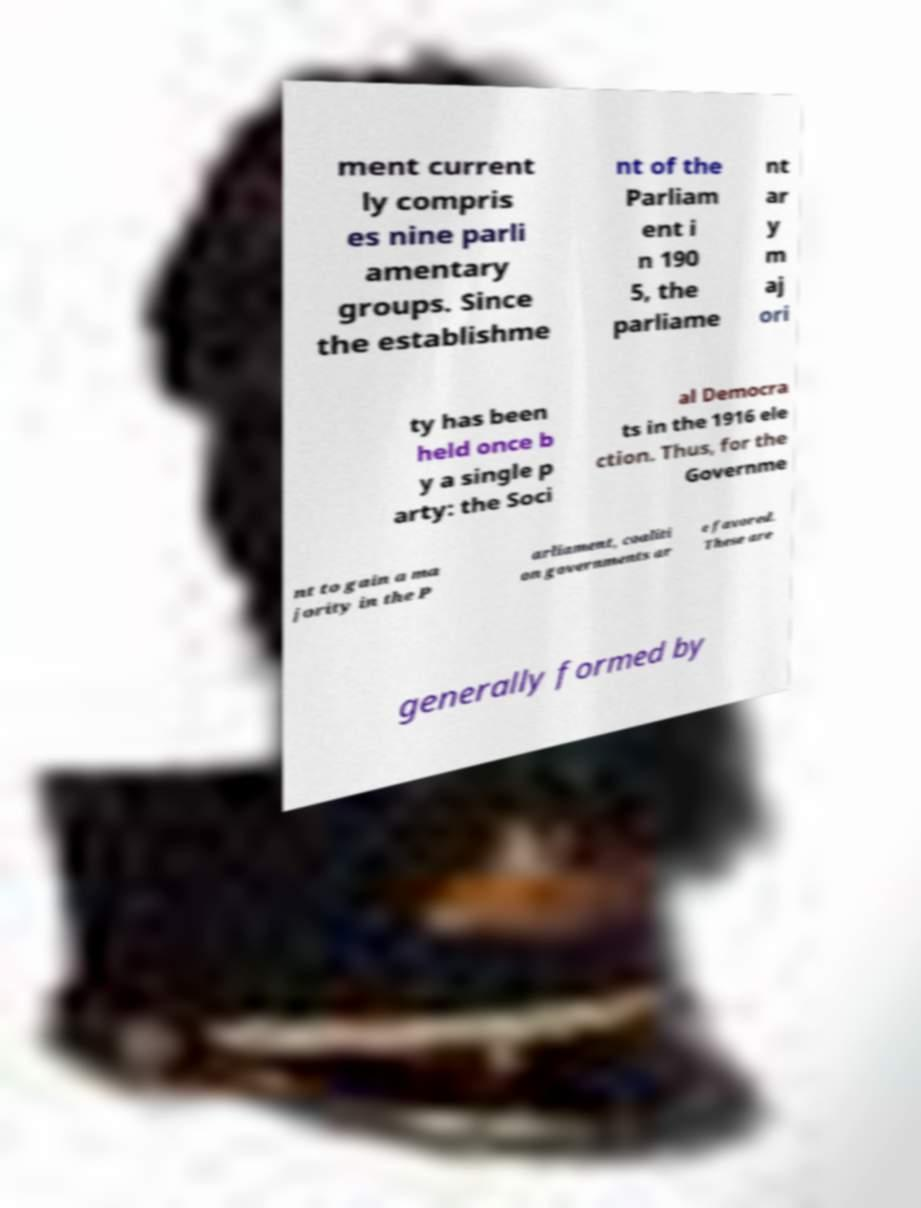Could you extract and type out the text from this image? ment current ly compris es nine parli amentary groups. Since the establishme nt of the Parliam ent i n 190 5, the parliame nt ar y m aj ori ty has been held once b y a single p arty: the Soci al Democra ts in the 1916 ele ction. Thus, for the Governme nt to gain a ma jority in the P arliament, coaliti on governments ar e favored. These are generally formed by 